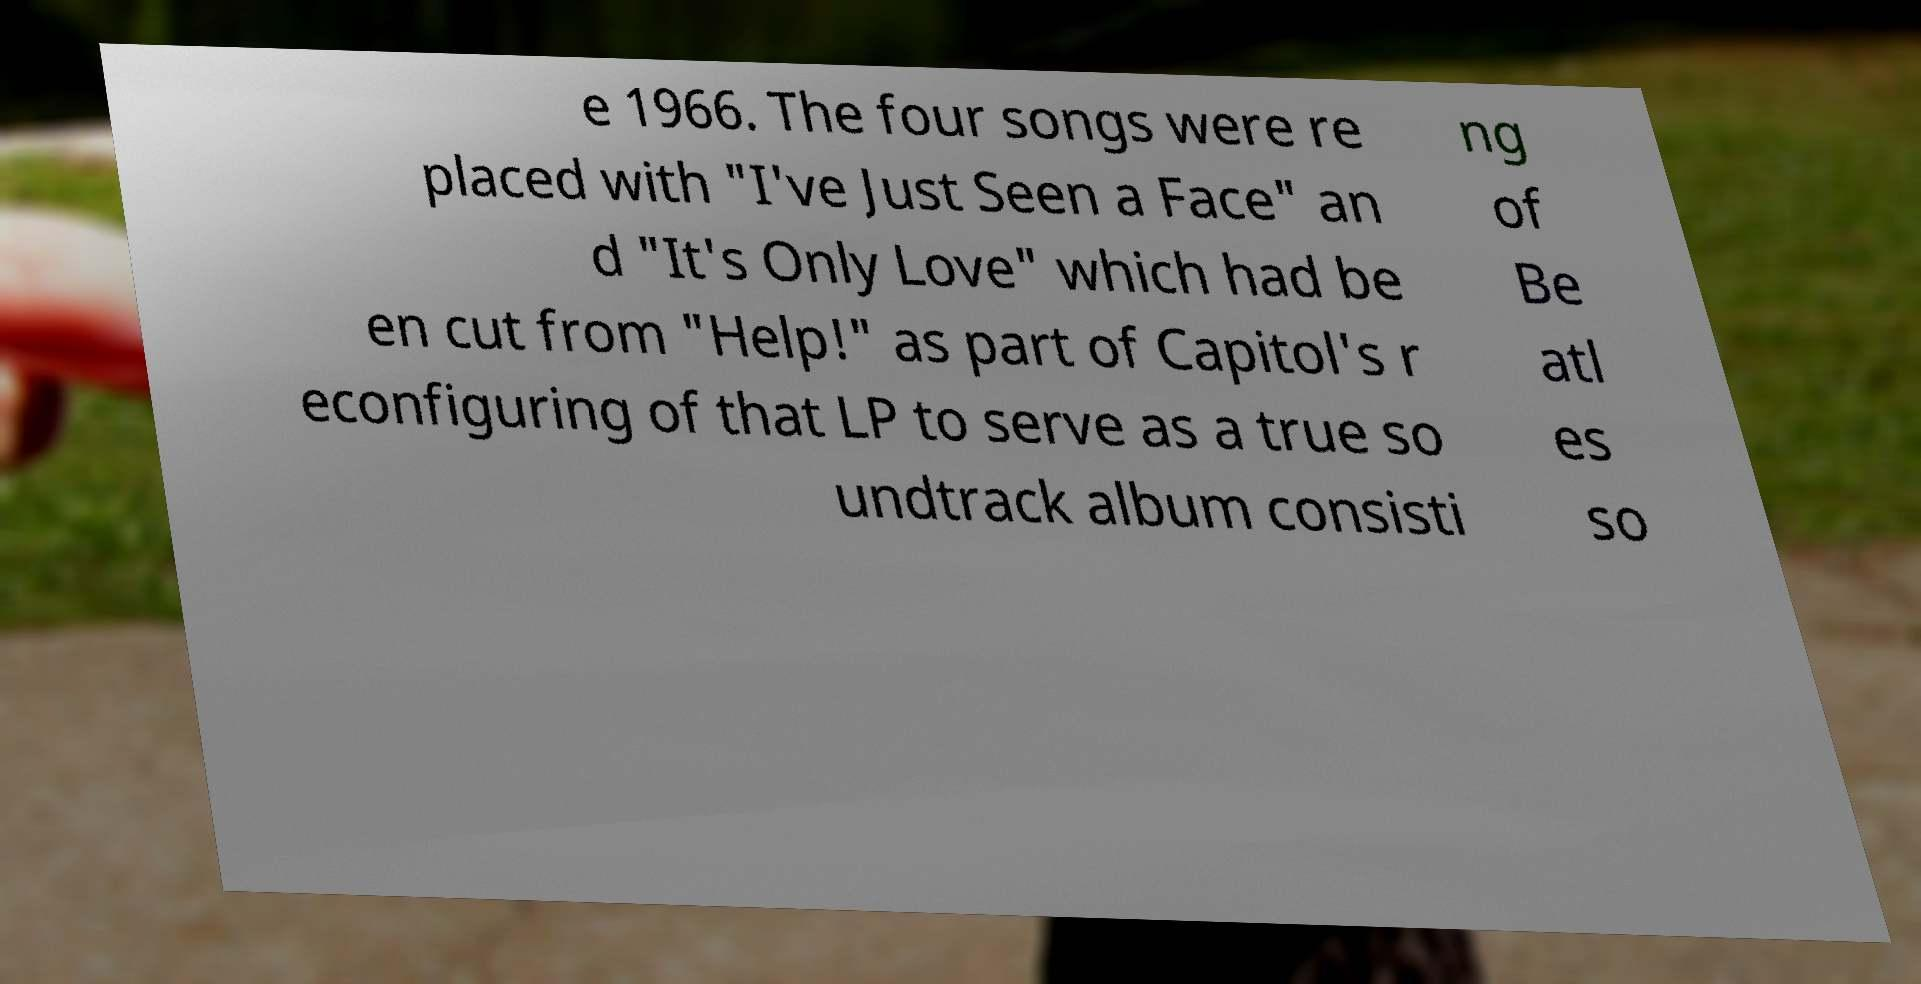I need the written content from this picture converted into text. Can you do that? e 1966. The four songs were re placed with "I've Just Seen a Face" an d "It's Only Love" which had be en cut from "Help!" as part of Capitol's r econfiguring of that LP to serve as a true so undtrack album consisti ng of Be atl es so 